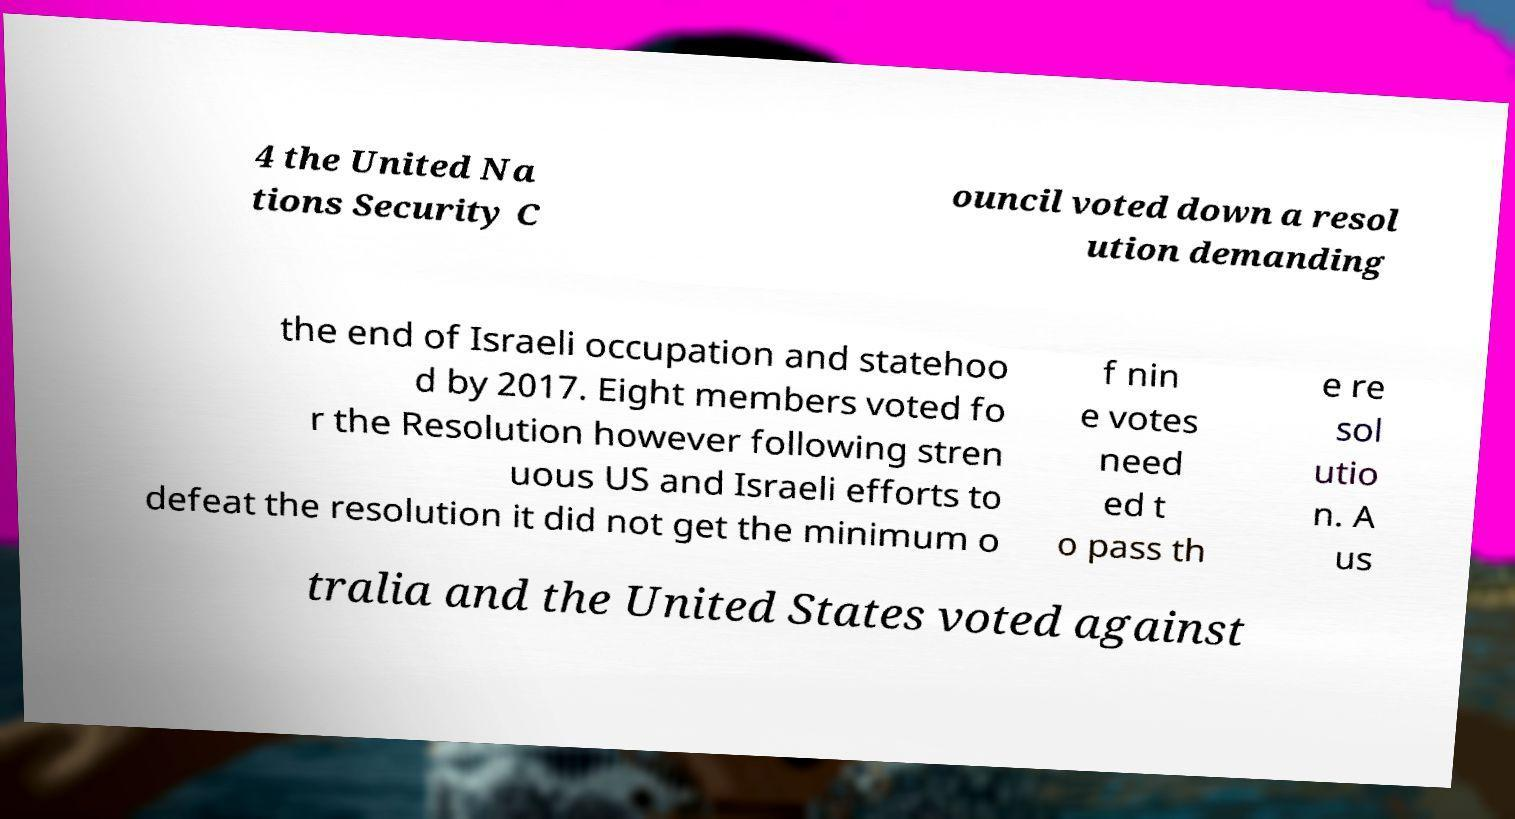Could you assist in decoding the text presented in this image and type it out clearly? 4 the United Na tions Security C ouncil voted down a resol ution demanding the end of Israeli occupation and statehoo d by 2017. Eight members voted fo r the Resolution however following stren uous US and Israeli efforts to defeat the resolution it did not get the minimum o f nin e votes need ed t o pass th e re sol utio n. A us tralia and the United States voted against 